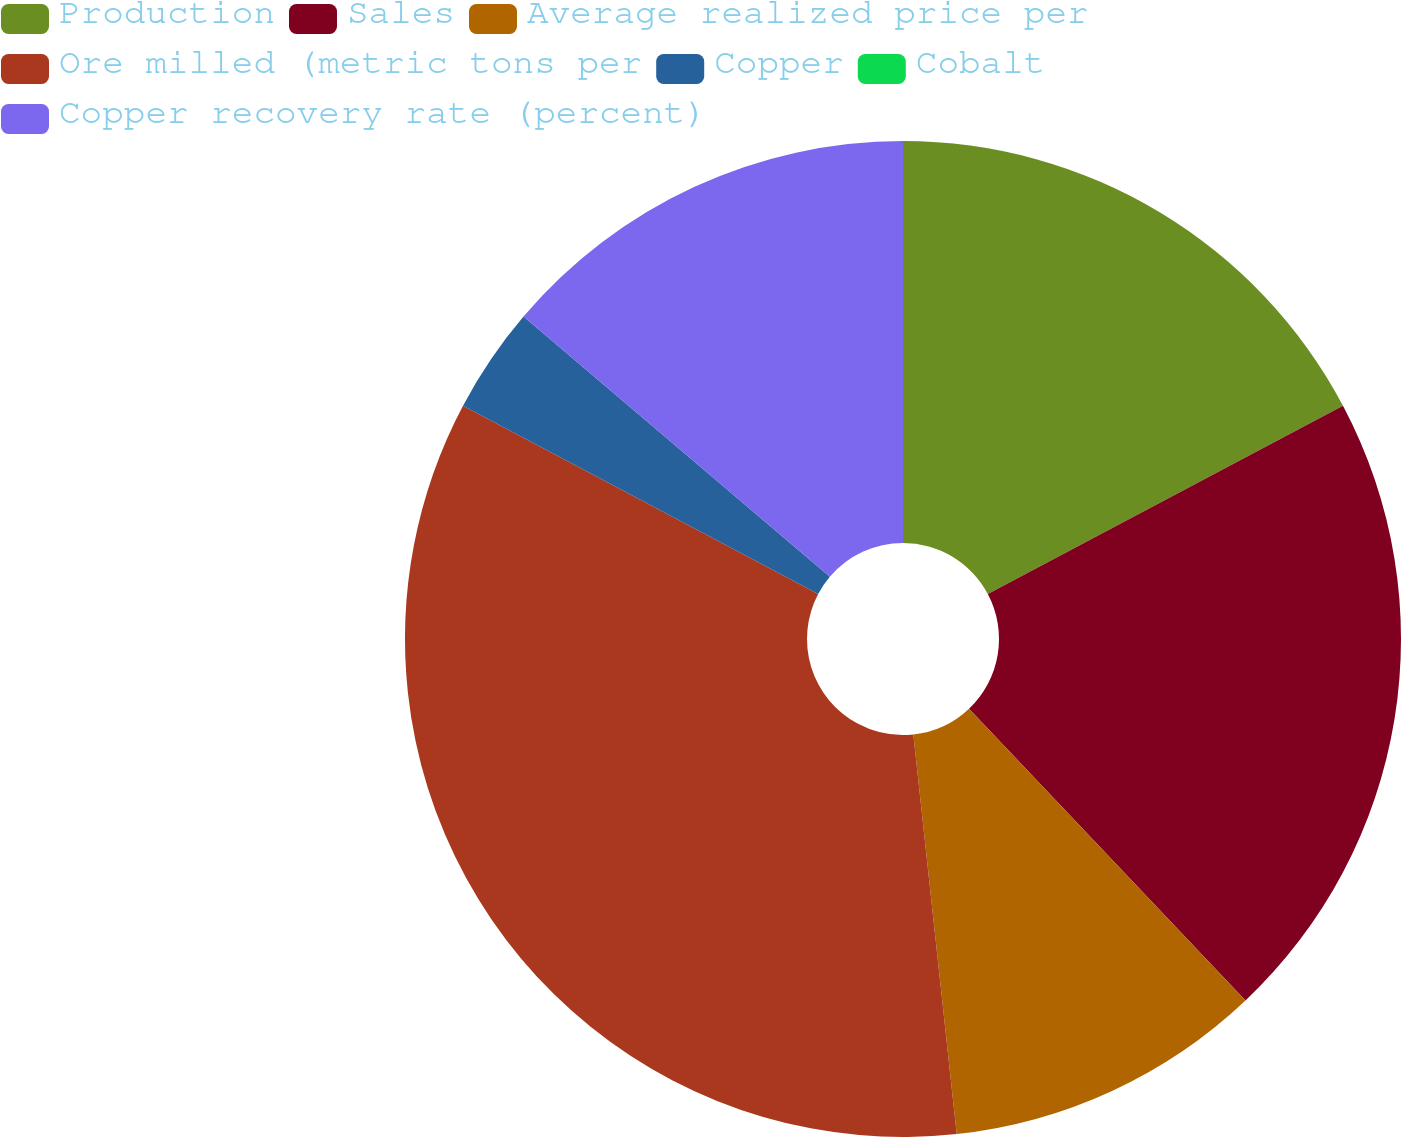Convert chart to OTSL. <chart><loc_0><loc_0><loc_500><loc_500><pie_chart><fcel>Production<fcel>Sales<fcel>Average realized price per<fcel>Ore milled (metric tons per<fcel>Copper<fcel>Cobalt<fcel>Copper recovery rate (percent)<nl><fcel>17.24%<fcel>20.69%<fcel>10.35%<fcel>34.48%<fcel>3.45%<fcel>0.0%<fcel>13.79%<nl></chart> 